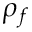Convert formula to latex. <formula><loc_0><loc_0><loc_500><loc_500>\rho _ { f }</formula> 